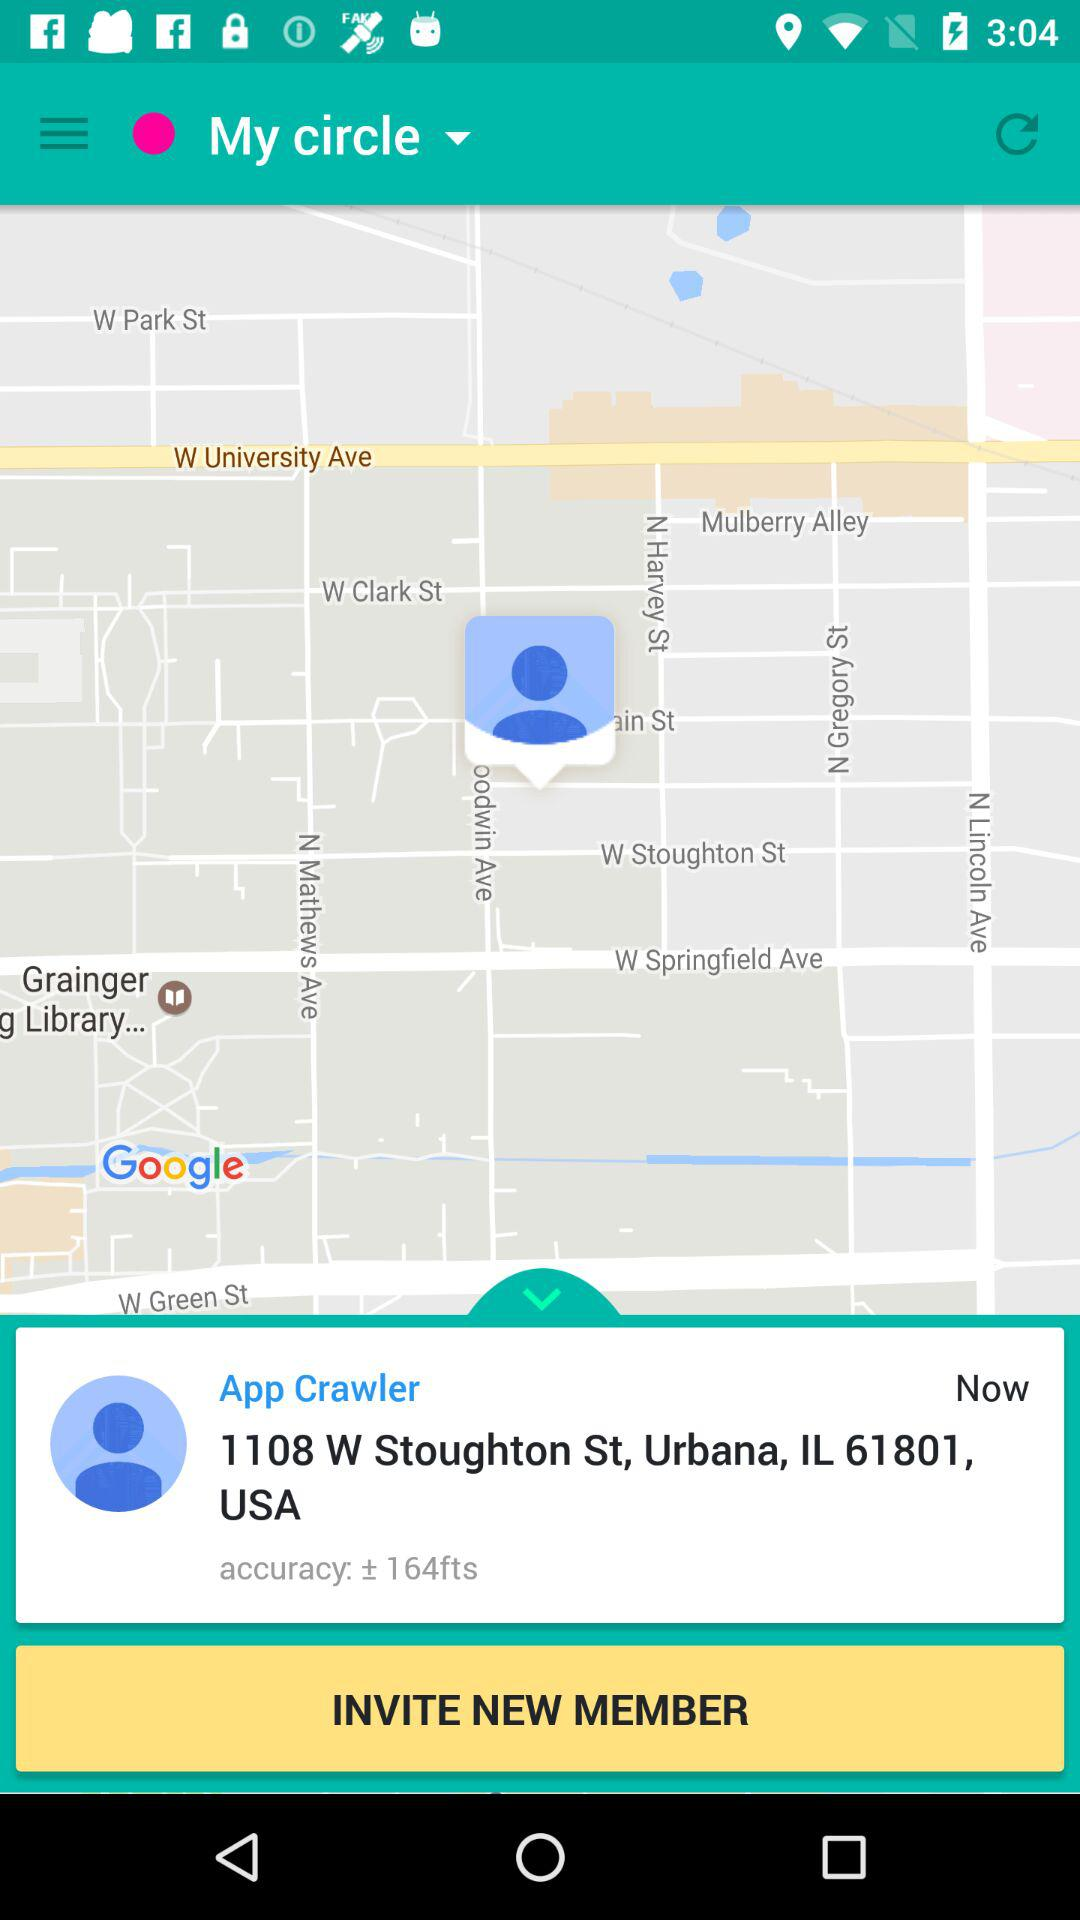How many feet is the accuracy of the location?
Answer the question using a single word or phrase. 164 